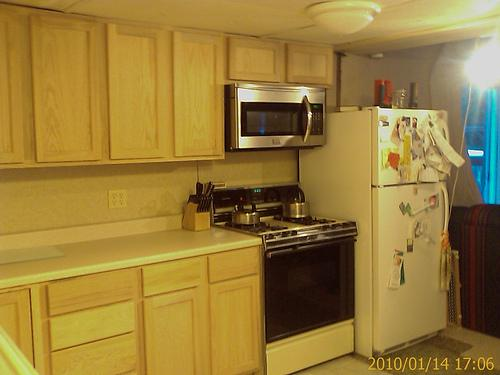What household food might you find in the object on the right?

Choices:
A) tinned fruit
B) peanuts
C) potato chips
D) milk milk 